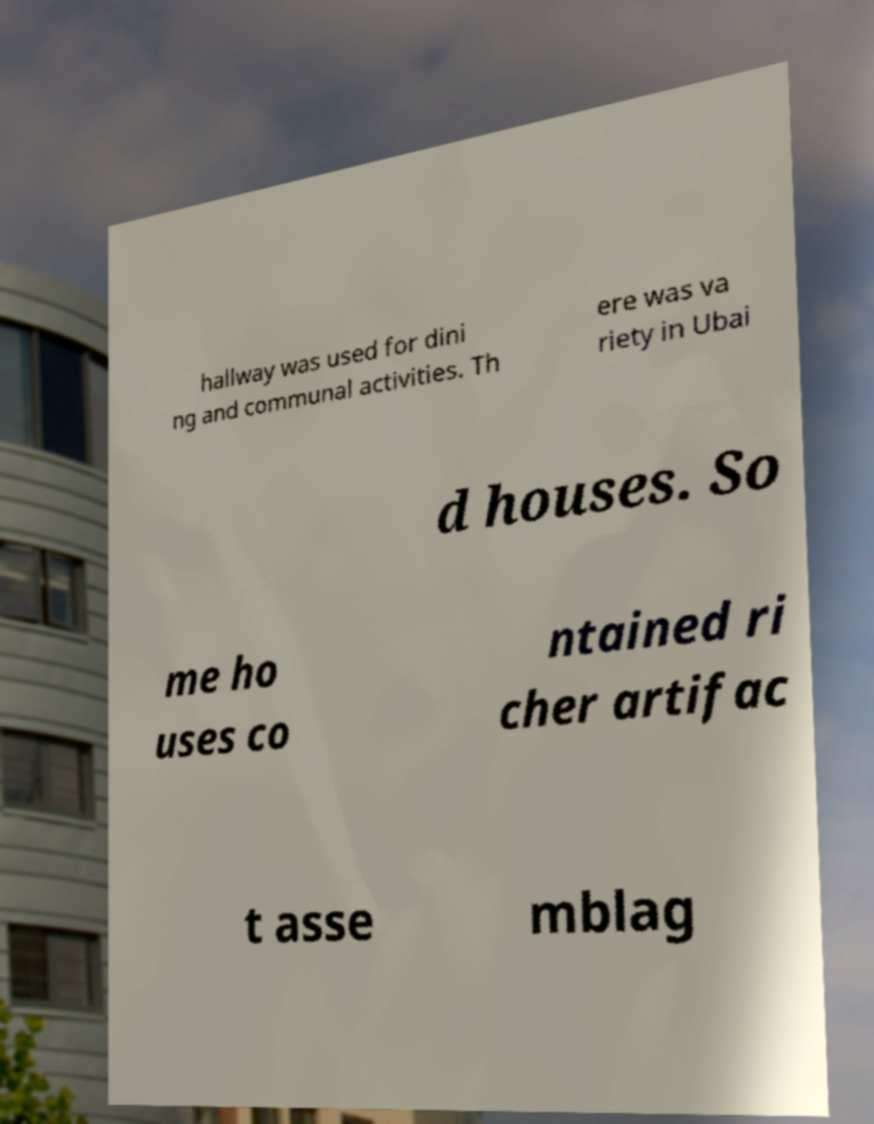Can you accurately transcribe the text from the provided image for me? hallway was used for dini ng and communal activities. Th ere was va riety in Ubai d houses. So me ho uses co ntained ri cher artifac t asse mblag 